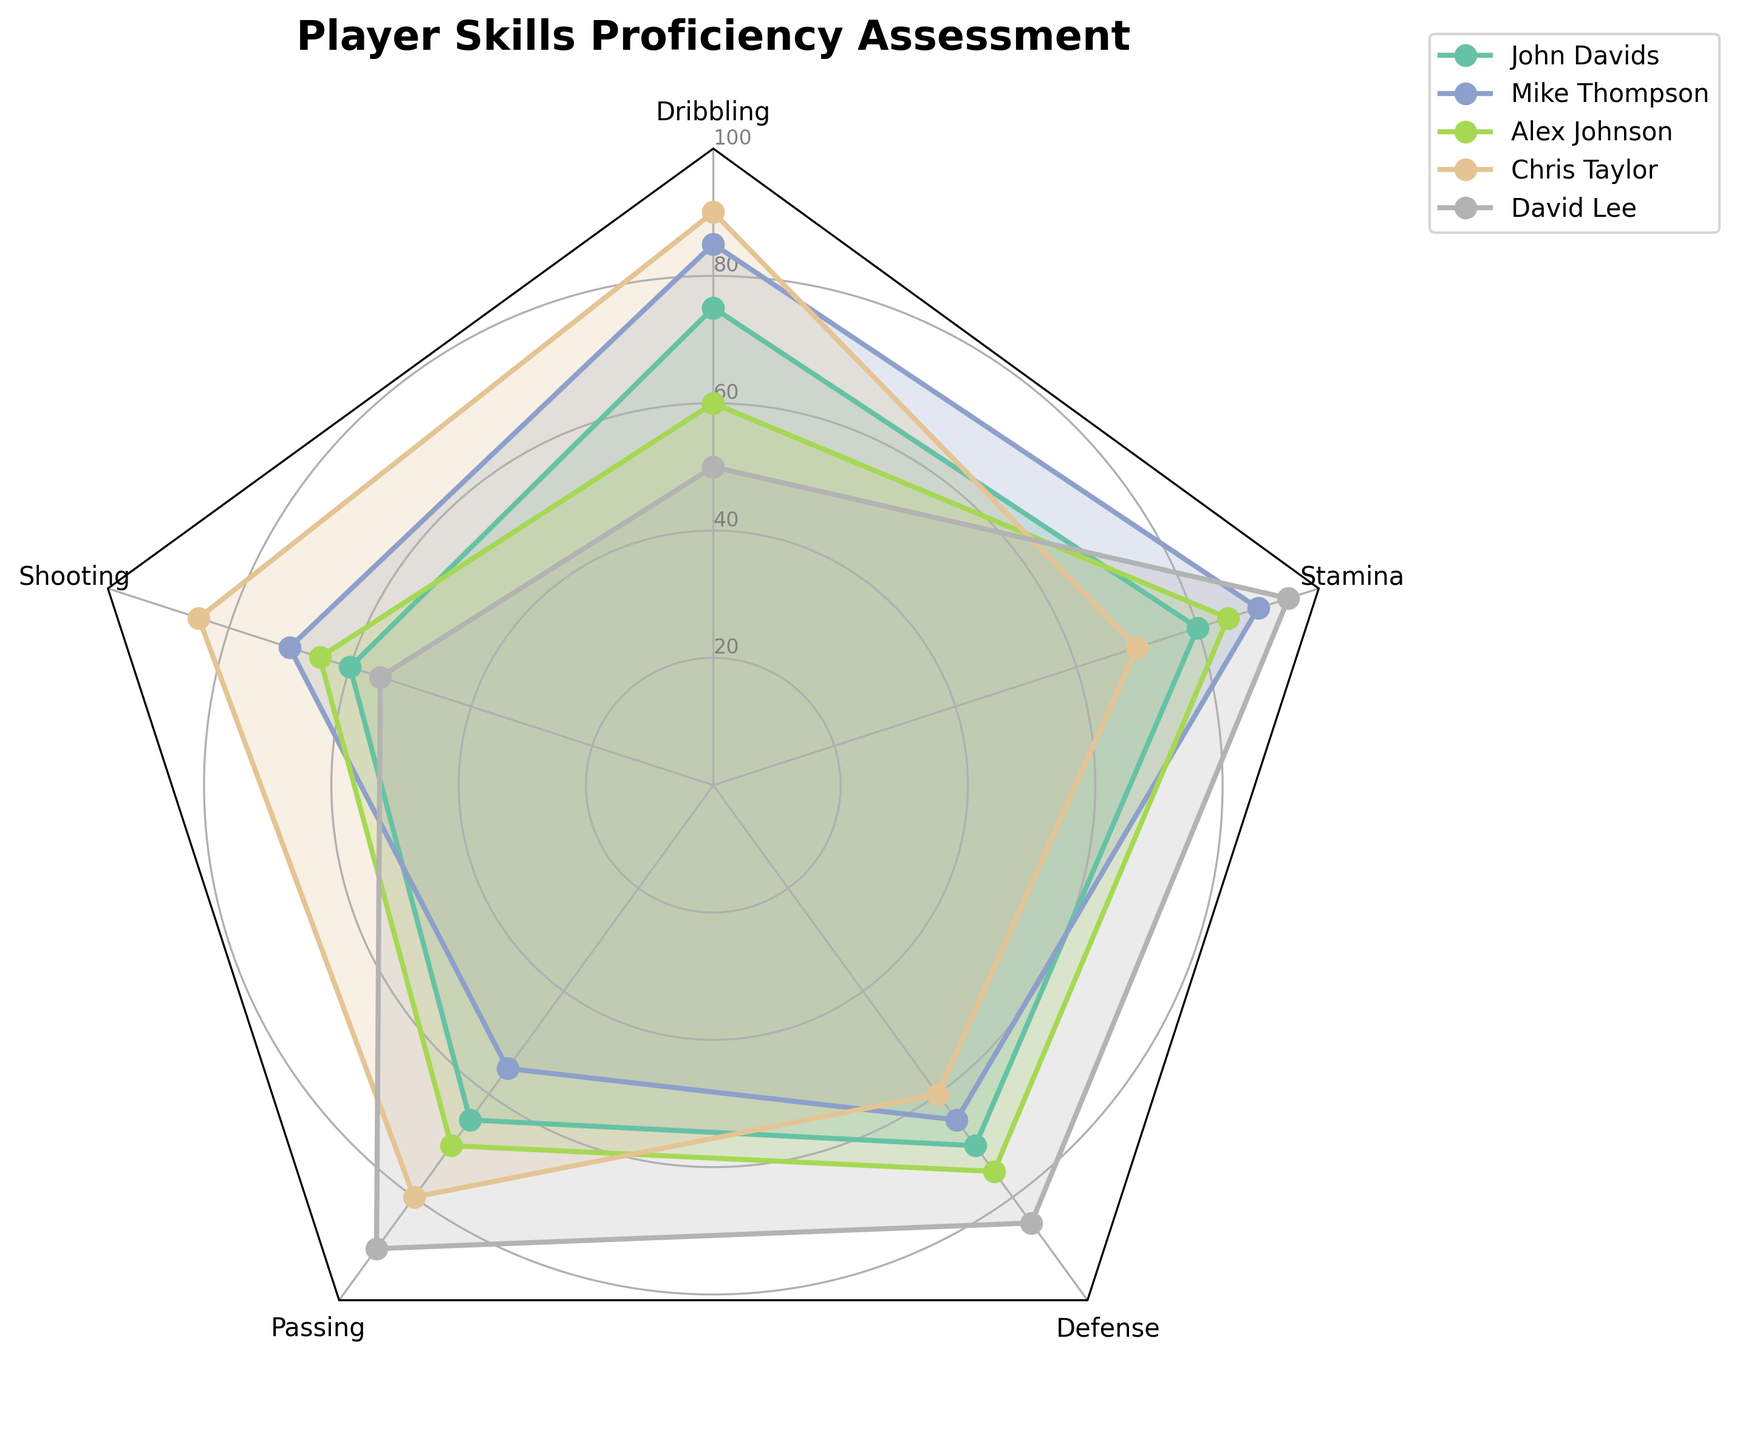What is the title of the chart? The title is usually located at the top of the chart. In this case, the chart title is "Player Skills Proficiency Assessment".
Answer: Player Skills Proficiency Assessment How many players' skills are shown in the radar chart? To find the number of players, we count the number of unique labels in the legend. The legend shows five players: John Davids, Mike Thompson, Alex Johnson, Chris Taylor, David Lee.
Answer: Five Which player has the highest stamina rating? Look at the stamina axis on the radar chart and compare the endpoints of the lines. The player with the line reaching the furthest on the stamina axis is David Lee.
Answer: David Lee Who has the best average skill level across all categories? To determine the average skill level, calculate the mean for each player’s scores and compare. Average for each player: 
- John Davids = (75+60+65+70+80)/5 = 70
- Mike Thompson = (85+70+55+65+90)/5 = 73
- Alex Johnson = (60+65+70+75+85)/5 = 71
- Chris Taylor = (90+85+80+60+70)/5 = 77
- David Lee = (50+55+90+85+95)/5 = 75
Answer: Chris Taylor Between Mike Thompson and Alex Johnson, who has better passing skills? Compare their scores on the passing axis. Mike Thompson has a passing score of 55, whereas Alex Johnson has a passing score of 70. Therefore, Alex Johnson has better passing skills.
Answer: Alex Johnson Which player has the lowest shooting proficiency? Compare the shooting scores of all players by looking at the endpoints of lines on the shooting axis. The player with the lowest endpoint is David Lee with a shooting score of 55.
Answer: David Lee By how many points does Chris Taylor's shooting skill surpass Alex Johnson's? Look at the shooting scores of both players. Chris Taylor has a shooting score of 85 and Alex Johnson has 65. The difference is 85 - 65 = 20 points.
Answer: 20 Which player shows the most balanced proficiency across all skills? A balanced player would have skills that are roughly equal across all categories, leading to a more circular shape in the radar chart. John Davids and Alex Johnson both show considerable balance, but Alex Johnson's deviations between skills are less pronounced.
Answer: Alex Johnson 